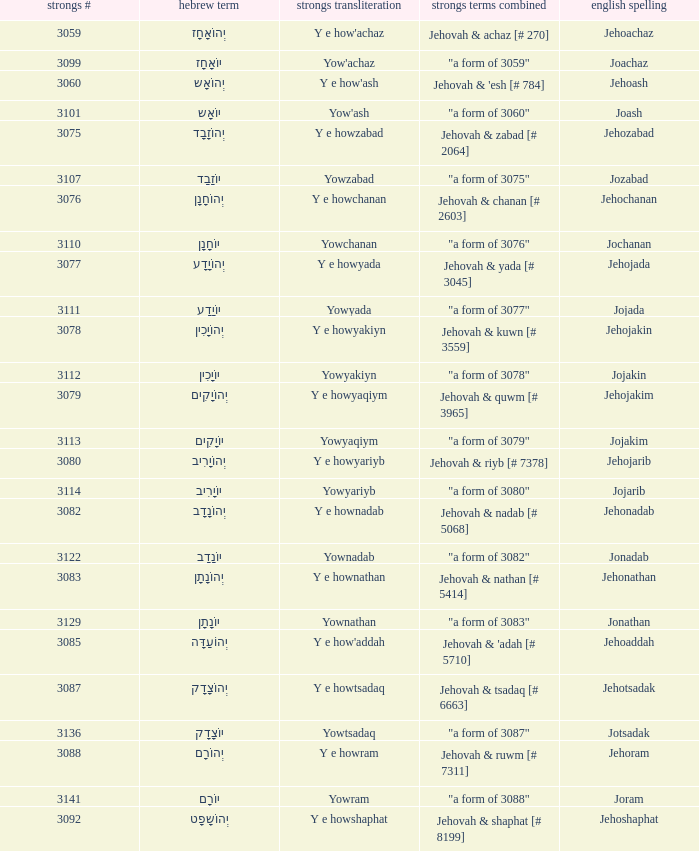What is the english spelling of the word that has the strongs trasliteration of y e howram? Jehoram. Can you give me this table as a dict? {'header': ['strongs #', 'hebrew term', 'strongs transliteration', 'strongs terms combined', 'english spelling'], 'rows': [['3059', 'יְהוֹאָחָז', "Y e how'achaz", 'Jehovah & achaz [# 270]', 'Jehoachaz'], ['3099', 'יוֹאָחָז', "Yow'achaz", '"a form of 3059"', 'Joachaz'], ['3060', 'יְהוֹאָש', "Y e how'ash", "Jehovah & 'esh [# 784]", 'Jehoash'], ['3101', 'יוֹאָש', "Yow'ash", '"a form of 3060"', 'Joash'], ['3075', 'יְהוֹזָבָד', 'Y e howzabad', 'Jehovah & zabad [# 2064]', 'Jehozabad'], ['3107', 'יוֹזָבָד', 'Yowzabad', '"a form of 3075"', 'Jozabad'], ['3076', 'יְהוֹחָנָן', 'Y e howchanan', 'Jehovah & chanan [# 2603]', 'Jehochanan'], ['3110', 'יוֹחָנָן', 'Yowchanan', '"a form of 3076"', 'Jochanan'], ['3077', 'יְהוֹיָדָע', 'Y e howyada', 'Jehovah & yada [# 3045]', 'Jehojada'], ['3111', 'יוֹיָדָע', 'Yowyada', '"a form of 3077"', 'Jojada'], ['3078', 'יְהוֹיָכִין', 'Y e howyakiyn', 'Jehovah & kuwn [# 3559]', 'Jehojakin'], ['3112', 'יוֹיָכִין', 'Yowyakiyn', '"a form of 3078"', 'Jojakin'], ['3079', 'יְהוֹיָקִים', 'Y e howyaqiym', 'Jehovah & quwm [# 3965]', 'Jehojakim'], ['3113', 'יוֹיָקִים', 'Yowyaqiym', '"a form of 3079"', 'Jojakim'], ['3080', 'יְהוֹיָרִיב', 'Y e howyariyb', 'Jehovah & riyb [# 7378]', 'Jehojarib'], ['3114', 'יוֹיָרִיב', 'Yowyariyb', '"a form of 3080"', 'Jojarib'], ['3082', 'יְהוֹנָדָב', 'Y e hownadab', 'Jehovah & nadab [# 5068]', 'Jehonadab'], ['3122', 'יוֹנָדָב', 'Yownadab', '"a form of 3082"', 'Jonadab'], ['3083', 'יְהוֹנָתָן', 'Y e hownathan', 'Jehovah & nathan [# 5414]', 'Jehonathan'], ['3129', 'יוֹנָתָן', 'Yownathan', '"a form of 3083"', 'Jonathan'], ['3085', 'יְהוֹעַדָּה', "Y e how'addah", "Jehovah & 'adah [# 5710]", 'Jehoaddah'], ['3087', 'יְהוֹצָדָק', 'Y e howtsadaq', 'Jehovah & tsadaq [# 6663]', 'Jehotsadak'], ['3136', 'יוֹצָדָק', 'Yowtsadaq', '"a form of 3087"', 'Jotsadak'], ['3088', 'יְהוֹרָם', 'Y e howram', 'Jehovah & ruwm [# 7311]', 'Jehoram'], ['3141', 'יוֹרָם', 'Yowram', '"a form of 3088"', 'Joram'], ['3092', 'יְהוֹשָפָט', 'Y e howshaphat', 'Jehovah & shaphat [# 8199]', 'Jehoshaphat']]} 